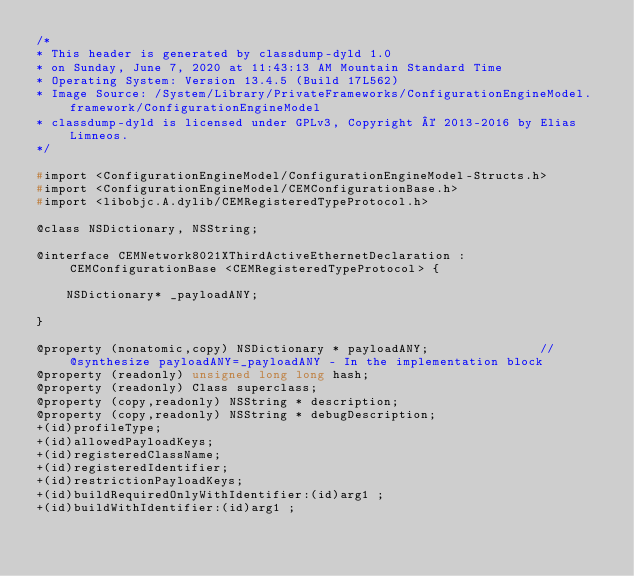<code> <loc_0><loc_0><loc_500><loc_500><_C_>/*
* This header is generated by classdump-dyld 1.0
* on Sunday, June 7, 2020 at 11:43:13 AM Mountain Standard Time
* Operating System: Version 13.4.5 (Build 17L562)
* Image Source: /System/Library/PrivateFrameworks/ConfigurationEngineModel.framework/ConfigurationEngineModel
* classdump-dyld is licensed under GPLv3, Copyright © 2013-2016 by Elias Limneos.
*/

#import <ConfigurationEngineModel/ConfigurationEngineModel-Structs.h>
#import <ConfigurationEngineModel/CEMConfigurationBase.h>
#import <libobjc.A.dylib/CEMRegisteredTypeProtocol.h>

@class NSDictionary, NSString;

@interface CEMNetwork8021XThirdActiveEthernetDeclaration : CEMConfigurationBase <CEMRegisteredTypeProtocol> {

	NSDictionary* _payloadANY;

}

@property (nonatomic,copy) NSDictionary * payloadANY;               //@synthesize payloadANY=_payloadANY - In the implementation block
@property (readonly) unsigned long long hash; 
@property (readonly) Class superclass; 
@property (copy,readonly) NSString * description; 
@property (copy,readonly) NSString * debugDescription; 
+(id)profileType;
+(id)allowedPayloadKeys;
+(id)registeredClassName;
+(id)registeredIdentifier;
+(id)restrictionPayloadKeys;
+(id)buildRequiredOnlyWithIdentifier:(id)arg1 ;
+(id)buildWithIdentifier:(id)arg1 ;</code> 